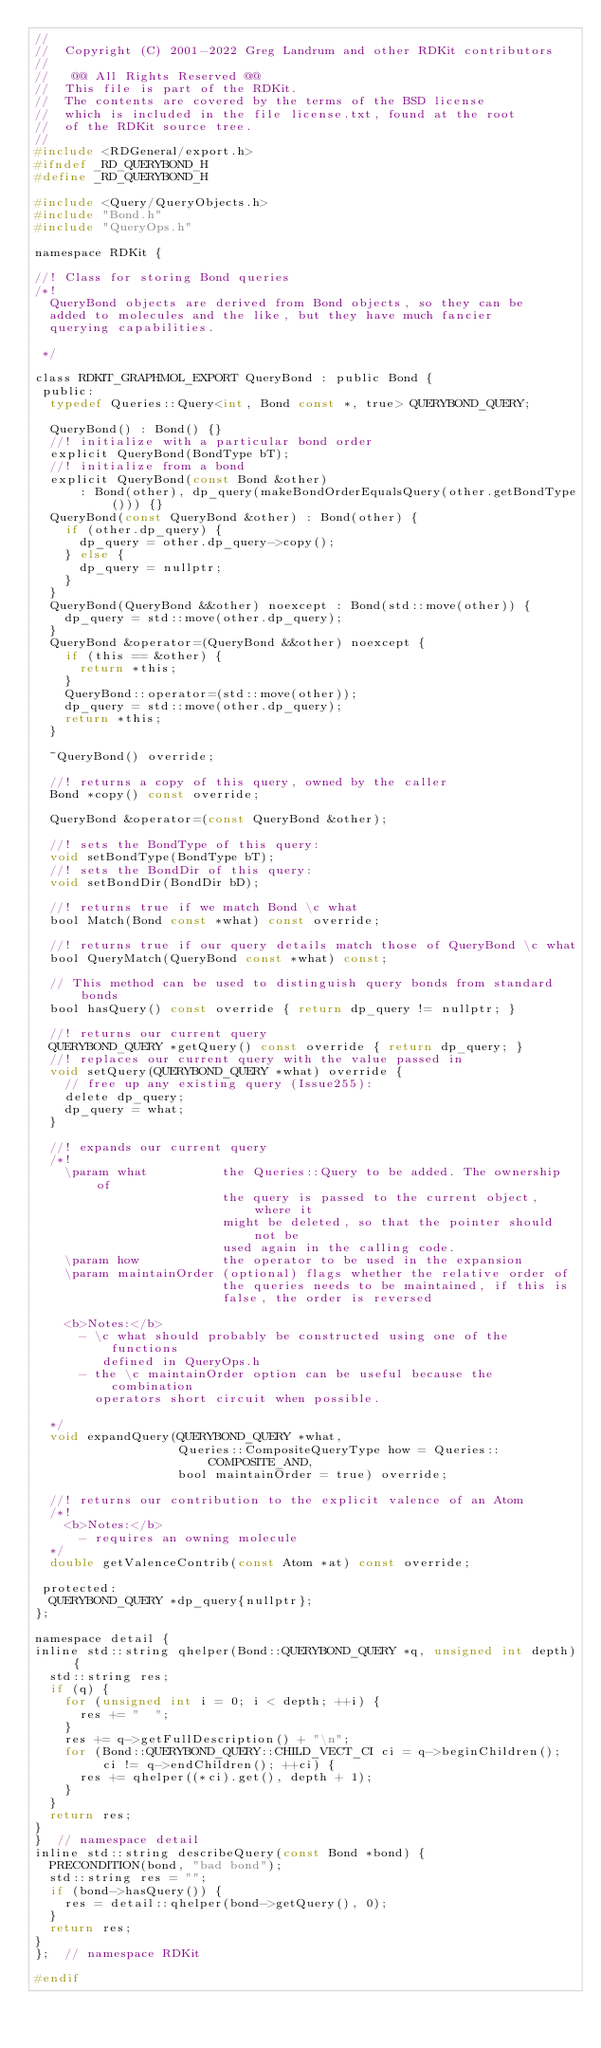Convert code to text. <code><loc_0><loc_0><loc_500><loc_500><_C_>//
//  Copyright (C) 2001-2022 Greg Landrum and other RDKit contributors
//
//   @@ All Rights Reserved @@
//  This file is part of the RDKit.
//  The contents are covered by the terms of the BSD license
//  which is included in the file license.txt, found at the root
//  of the RDKit source tree.
//
#include <RDGeneral/export.h>
#ifndef _RD_QUERYBOND_H
#define _RD_QUERYBOND_H

#include <Query/QueryObjects.h>
#include "Bond.h"
#include "QueryOps.h"

namespace RDKit {

//! Class for storing Bond queries
/*!
  QueryBond objects are derived from Bond objects, so they can be
  added to molecules and the like, but they have much fancier
  querying capabilities.

 */

class RDKIT_GRAPHMOL_EXPORT QueryBond : public Bond {
 public:
  typedef Queries::Query<int, Bond const *, true> QUERYBOND_QUERY;

  QueryBond() : Bond() {}
  //! initialize with a particular bond order
  explicit QueryBond(BondType bT);
  //! initialize from a bond
  explicit QueryBond(const Bond &other)
      : Bond(other), dp_query(makeBondOrderEqualsQuery(other.getBondType())) {}
  QueryBond(const QueryBond &other) : Bond(other) {
    if (other.dp_query) {
      dp_query = other.dp_query->copy();
    } else {
      dp_query = nullptr;
    }
  }
  QueryBond(QueryBond &&other) noexcept : Bond(std::move(other)) {
    dp_query = std::move(other.dp_query);
  }
  QueryBond &operator=(QueryBond &&other) noexcept {
    if (this == &other) {
      return *this;
    }
    QueryBond::operator=(std::move(other));
    dp_query = std::move(other.dp_query);
    return *this;
  }

  ~QueryBond() override;

  //! returns a copy of this query, owned by the caller
  Bond *copy() const override;

  QueryBond &operator=(const QueryBond &other);

  //! sets the BondType of this query:
  void setBondType(BondType bT);
  //! sets the BondDir of this query:
  void setBondDir(BondDir bD);

  //! returns true if we match Bond \c what
  bool Match(Bond const *what) const override;

  //! returns true if our query details match those of QueryBond \c what
  bool QueryMatch(QueryBond const *what) const;

  // This method can be used to distinguish query bonds from standard bonds
  bool hasQuery() const override { return dp_query != nullptr; }

  //! returns our current query
  QUERYBOND_QUERY *getQuery() const override { return dp_query; }
  //! replaces our current query with the value passed in
  void setQuery(QUERYBOND_QUERY *what) override {
    // free up any existing query (Issue255):
    delete dp_query;
    dp_query = what;
  }

  //! expands our current query
  /*!
    \param what          the Queries::Query to be added. The ownership of
                         the query is passed to the current object, where it
                         might be deleted, so that the pointer should not be
                         used again in the calling code.
    \param how           the operator to be used in the expansion
    \param maintainOrder (optional) flags whether the relative order of
                         the queries needs to be maintained, if this is
                         false, the order is reversed

    <b>Notes:</b>
      - \c what should probably be constructed using one of the functions
         defined in QueryOps.h
      - the \c maintainOrder option can be useful because the combination
        operators short circuit when possible.

  */
  void expandQuery(QUERYBOND_QUERY *what,
                   Queries::CompositeQueryType how = Queries::COMPOSITE_AND,
                   bool maintainOrder = true) override;

  //! returns our contribution to the explicit valence of an Atom
  /*!
    <b>Notes:</b>
      - requires an owning molecule
  */
  double getValenceContrib(const Atom *at) const override;

 protected:
  QUERYBOND_QUERY *dp_query{nullptr};
};

namespace detail {
inline std::string qhelper(Bond::QUERYBOND_QUERY *q, unsigned int depth) {
  std::string res;
  if (q) {
    for (unsigned int i = 0; i < depth; ++i) {
      res += "  ";
    }
    res += q->getFullDescription() + "\n";
    for (Bond::QUERYBOND_QUERY::CHILD_VECT_CI ci = q->beginChildren();
         ci != q->endChildren(); ++ci) {
      res += qhelper((*ci).get(), depth + 1);
    }
  }
  return res;
}
}  // namespace detail
inline std::string describeQuery(const Bond *bond) {
  PRECONDITION(bond, "bad bond");
  std::string res = "";
  if (bond->hasQuery()) {
    res = detail::qhelper(bond->getQuery(), 0);
  }
  return res;
}
};  // namespace RDKit

#endif
</code> 